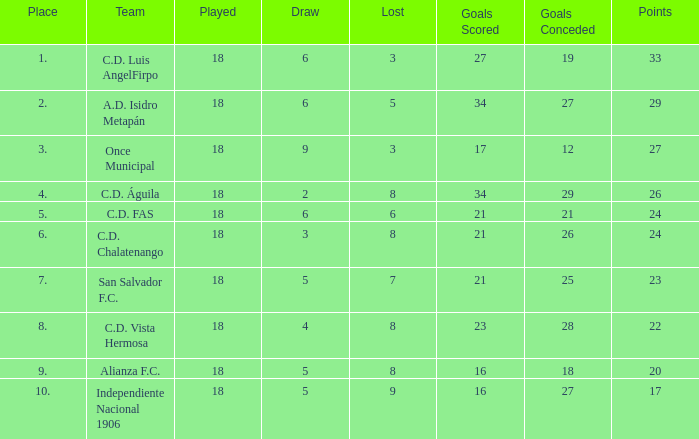In which instances were goals conceded that caused a loss of more than 8 and beyond 17 points? None. 